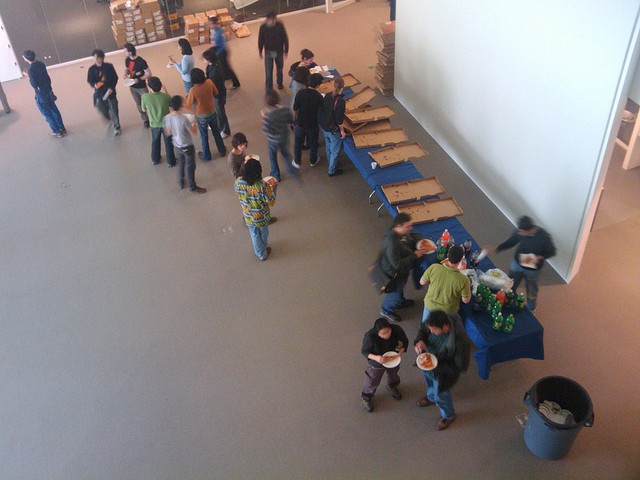Describe the objects in this image and their specific colors. I can see people in gray, black, and tan tones, people in gray, black, navy, and maroon tones, people in gray, black, and blue tones, people in gray, black, maroon, and brown tones, and people in gray, black, and darkblue tones in this image. 